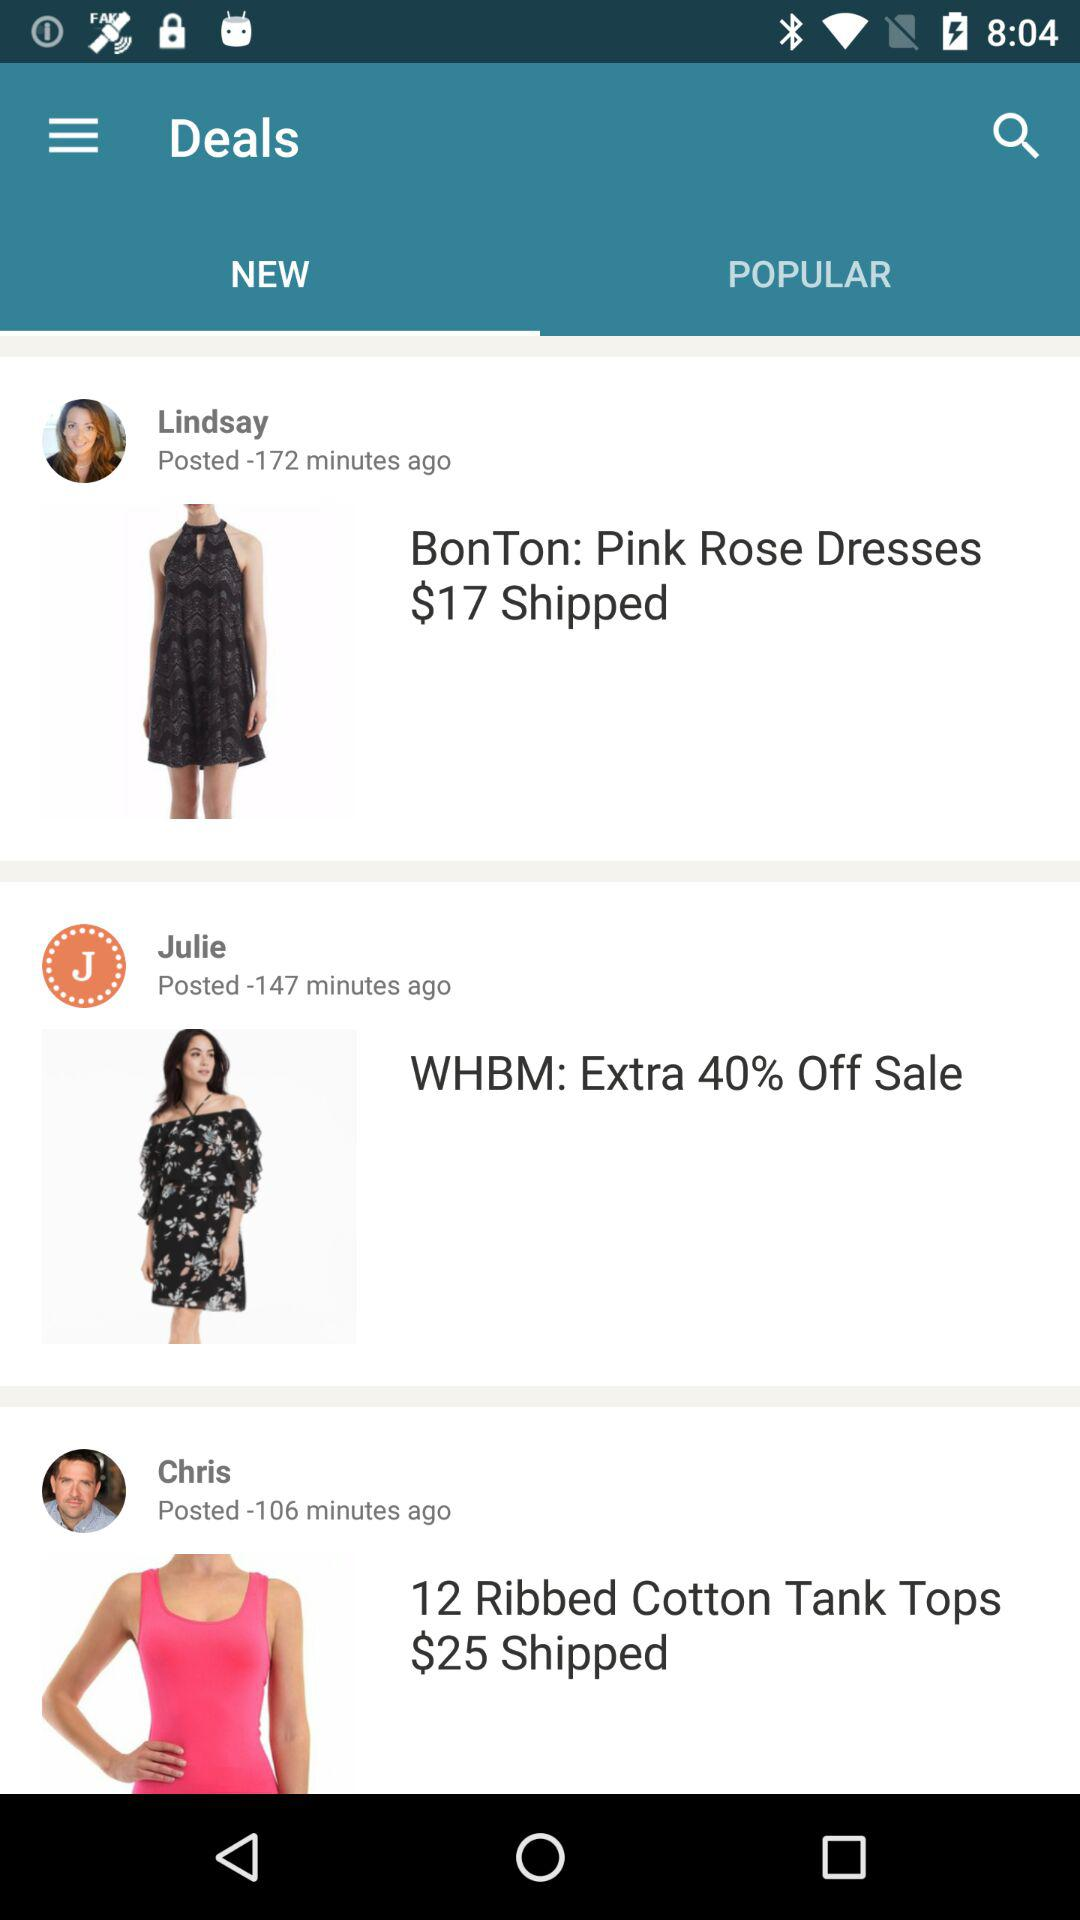How much extra is off on sale? There is 40% extra off on sales. 